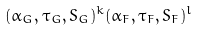Convert formula to latex. <formula><loc_0><loc_0><loc_500><loc_500>( \alpha _ { G } , \tau _ { G } , S _ { G } ) ^ { k } ( \alpha _ { F } , \tau _ { F } , S _ { F } ) ^ { l }</formula> 